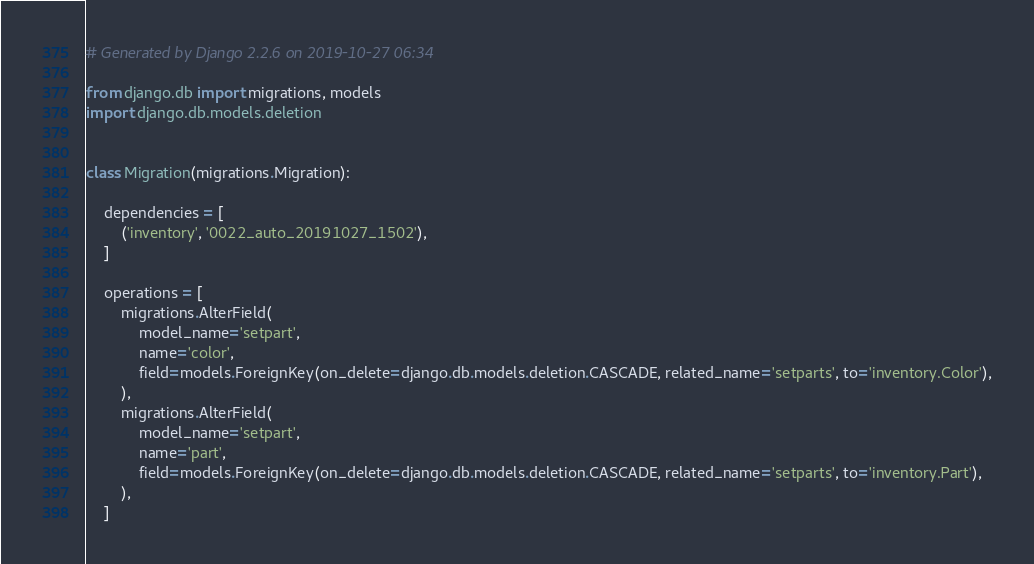Convert code to text. <code><loc_0><loc_0><loc_500><loc_500><_Python_># Generated by Django 2.2.6 on 2019-10-27 06:34

from django.db import migrations, models
import django.db.models.deletion


class Migration(migrations.Migration):

    dependencies = [
        ('inventory', '0022_auto_20191027_1502'),
    ]

    operations = [
        migrations.AlterField(
            model_name='setpart',
            name='color',
            field=models.ForeignKey(on_delete=django.db.models.deletion.CASCADE, related_name='setparts', to='inventory.Color'),
        ),
        migrations.AlterField(
            model_name='setpart',
            name='part',
            field=models.ForeignKey(on_delete=django.db.models.deletion.CASCADE, related_name='setparts', to='inventory.Part'),
        ),
    ]
</code> 